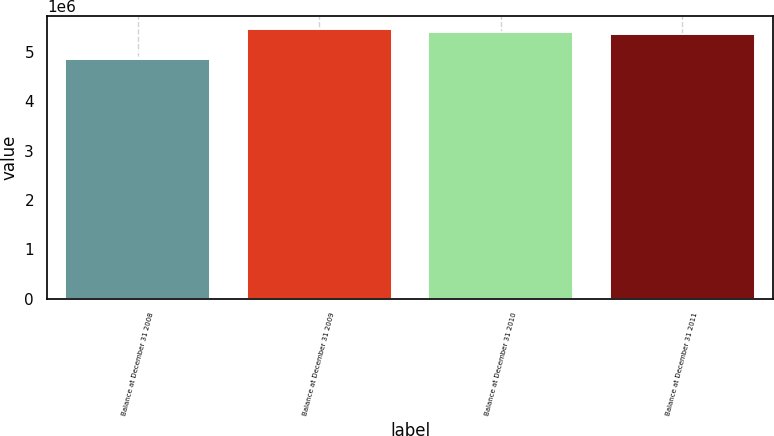Convert chart to OTSL. <chart><loc_0><loc_0><loc_500><loc_500><bar_chart><fcel>Balance at December 31 2008<fcel>Balance at December 31 2009<fcel>Balance at December 31 2010<fcel>Balance at December 31 2011<nl><fcel>4.8693e+06<fcel>5.46083e+06<fcel>5.41076e+06<fcel>5.36068e+06<nl></chart> 